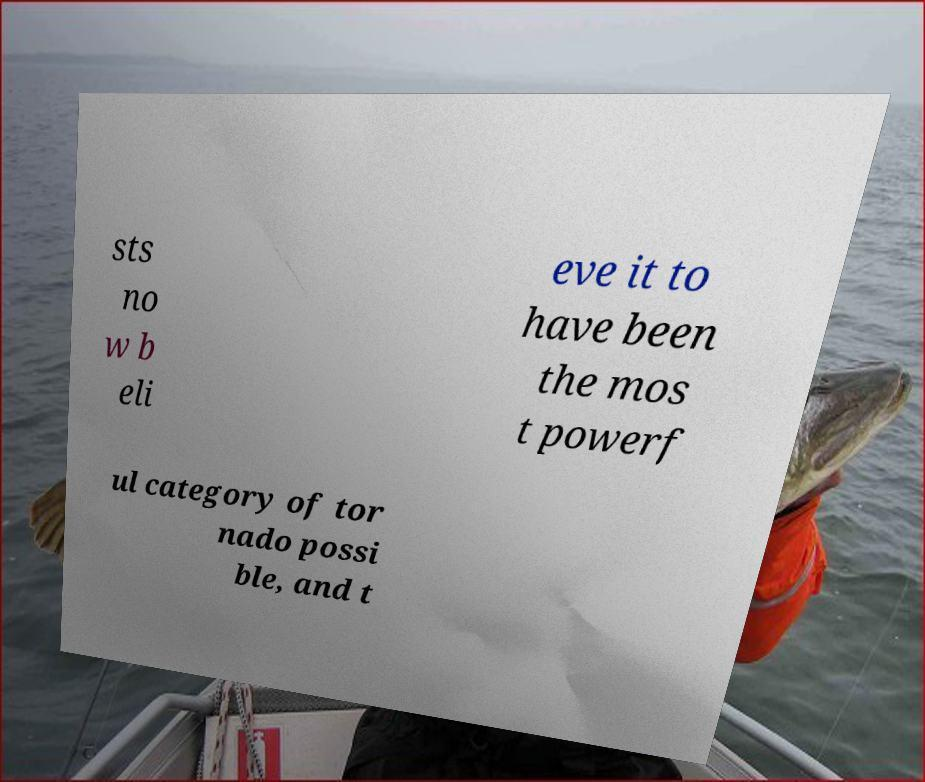Can you accurately transcribe the text from the provided image for me? sts no w b eli eve it to have been the mos t powerf ul category of tor nado possi ble, and t 